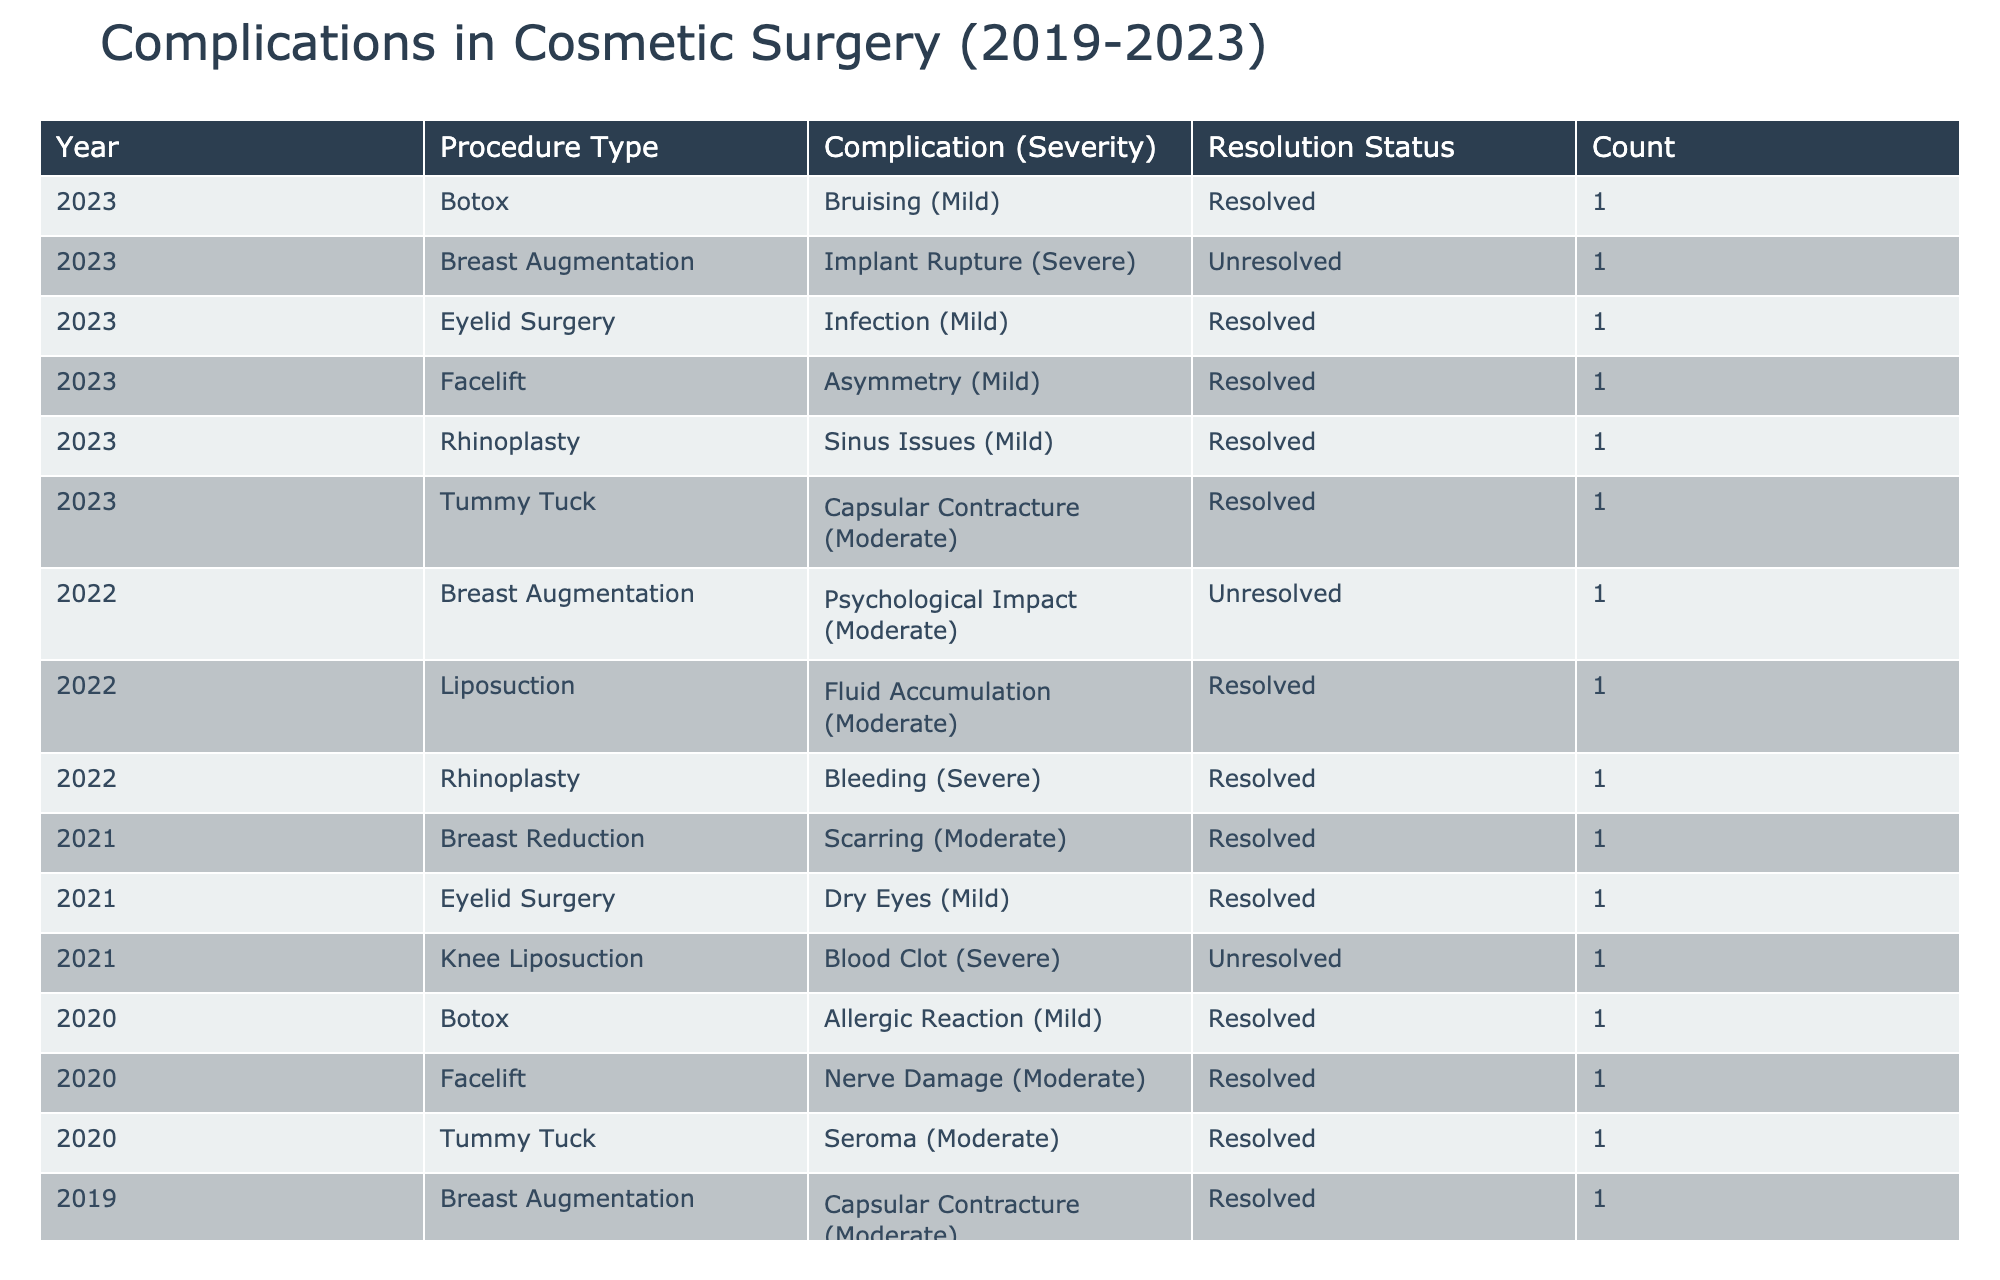What is the most common complication reported in breast augmentations? In the table, breast augmentations have two reported complications: "Capsular Contracture (Moderate)" and "Implant Rupture (Severe)". By examining the counts, "Capsular Contracture" has been reported more times (once in 2019 and once in 2023) than "Implant Rupture" (reported once in 2023), making it the most common.
Answer: Capsular Contracture Which procedure type had the highest overall number of complications reported? To find this, we need to sum the counts of complications for each procedure type across all years. Counting from the table: Breast Augmentation = 3, Rhinoplasty = 3, Liposuction = 3, Facelift = 2, Tummy Tuck = 2, Breast Reduction = 1, and Eyelid Surgery = 2. The highest total is 3 for Breast Augmentation, Rhinoplasty, and Liposuction.
Answer: Breast Augmentation, Rhinoplasty, Liposuction How many severe complications were reported across all years? The severe complications listed in the table are "Bleeding" from Liposuction in 2019, "Blood Clot" from Knee Liposuction in 2021, "Implant Rupture" from Breast Augmentation in 2023. Adding these gives us a total of 3 severe complications reported across the years.
Answer: 3 Was there any unresolved complication related to liposuction? Referring to the table, the unresolved complication for liposuction is "Bleeding (Severe)" from 2019 and "Blood Clot (Severe)" from 2021. Therefore, the answer is yes, there are unresolved complications related to liposuction.
Answer: Yes How many more complications were reported for rhinoplasty compared to facelift? First, we count the complications for rhinoplasty: 3 total (Infection, Bleeding, Sinus Issues). For facelift, there are 2 total complications (Nerve Damage, Asymmetry). The difference is 3 (rhinoplasty) - 2 (facelift) = 1.
Answer: 1 What age group showed the most severe complications, and what were they? From the table, the severe complications are associated with patients aged 45 (Liposuction in 2019), 50 (Knee Liposuction in 2021), and 45 (Breast Augmentation in 2023). Both ages are the same, so the age group is 45-50, and the complications are "Bleeding", "Blood Clot", and "Implant Rupture".
Answer: 45-50; Bleeding, Blood Clot, Implant Rupture How many complications were resolved in the year 2022? The table shows the complications resolved in 2022 are "Bleeding (Severe)", "Fluid Accumulation (Moderate)" from liposuction, and others that were resolved, giving us a total of 4 resolved complications.
Answer: 4 Which complication had the highest severity reported for breast reduction patients? In the table, the only complication for breast reduction is "Scarring (Moderate)", which does not have a severe rating. Therefore, all complications for breast reduction are moderate at best.
Answer: Moderate 